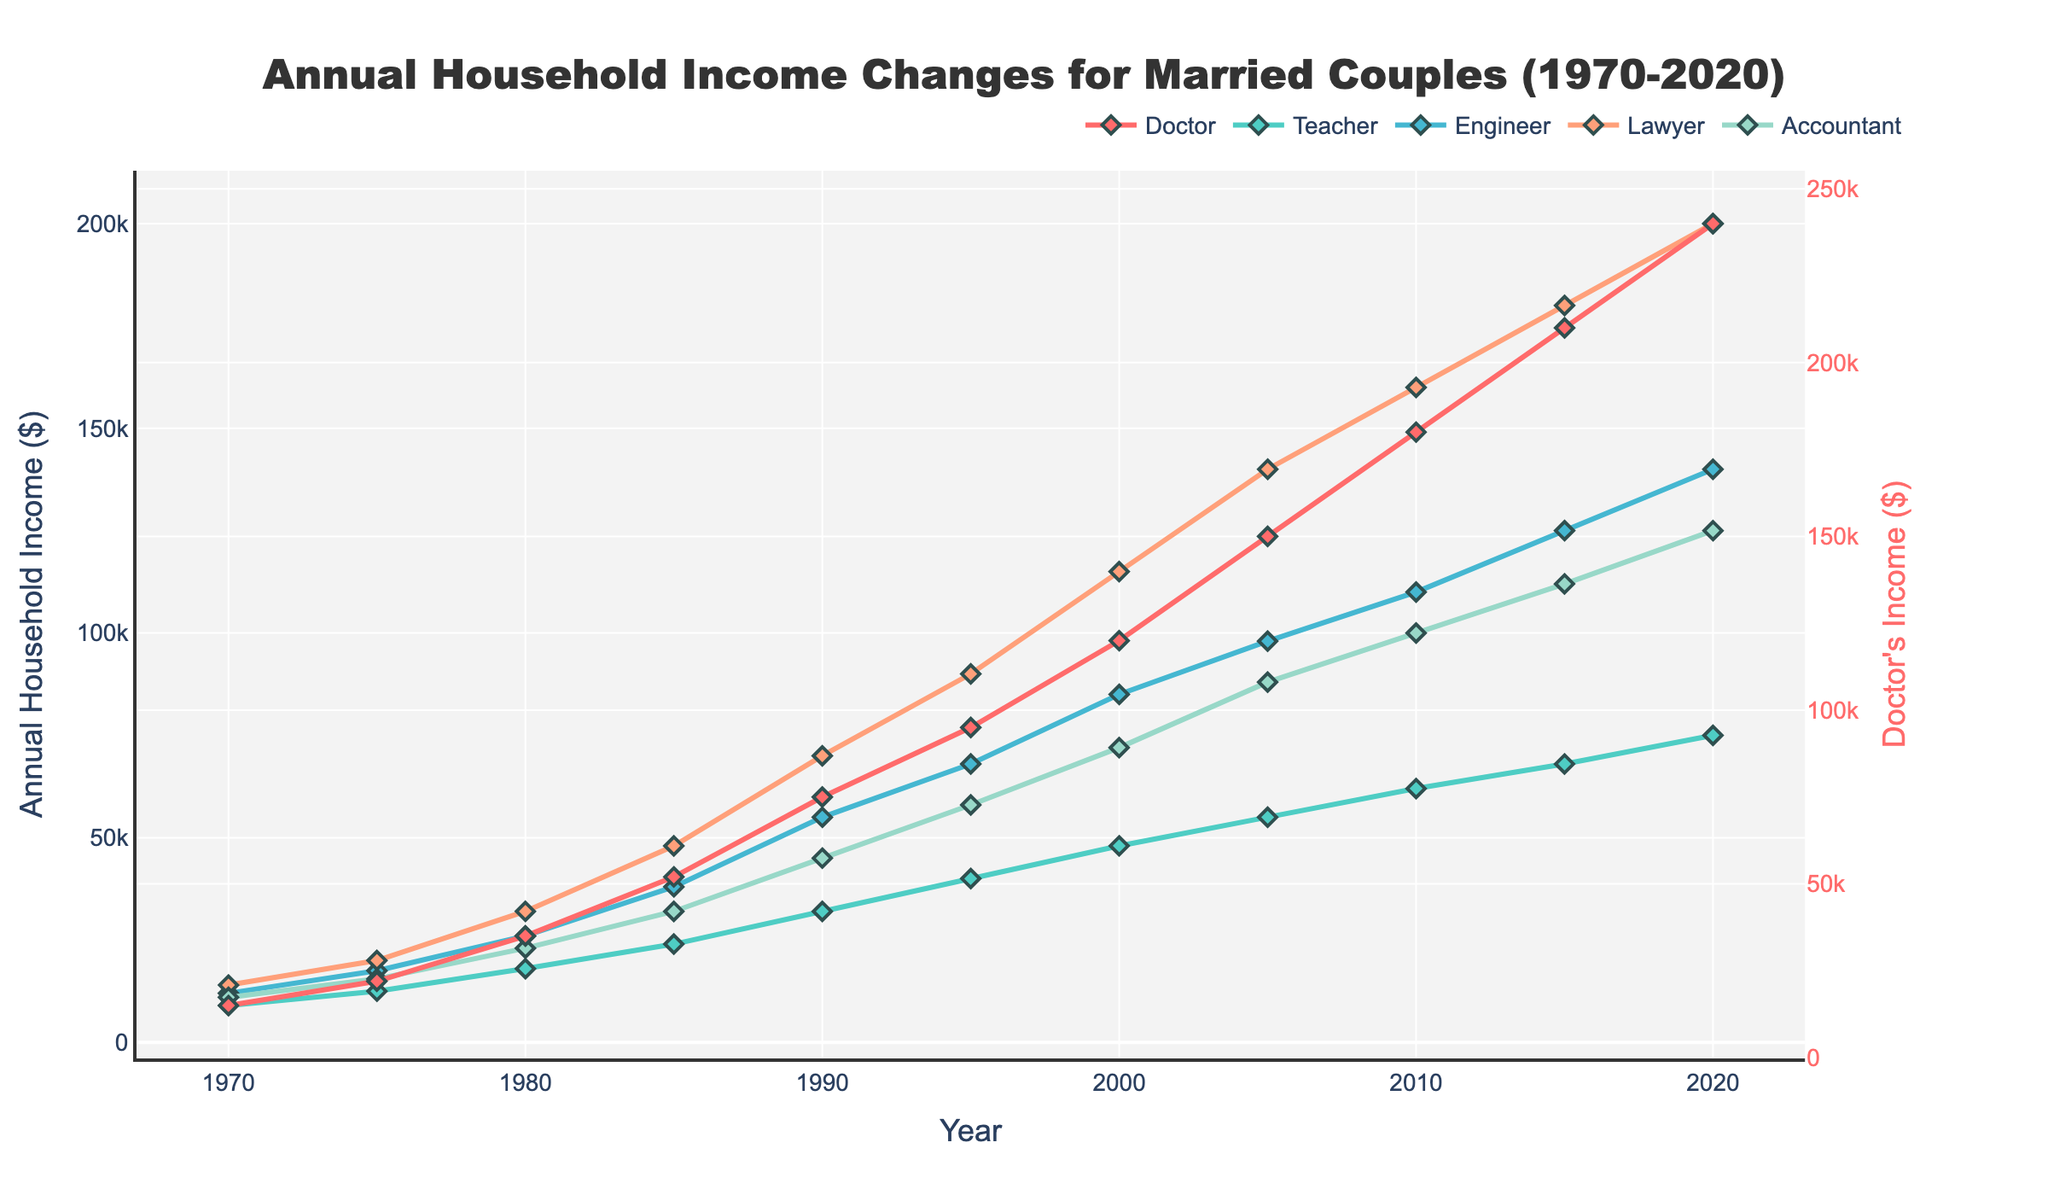What profession has the highest income in 2020? The line chart shows different professions and their incomes over the years. Looking at the year 2020, the highest income is noted for Doctors.
Answer: Doctor Which profession had the smallest increase in income from 1970 to 2020? By examining the line chart, check the starting and ending income values for each profession from 1970 to 2020. Teachers have the smallest increase as their income rises from $9,000 to $75,000, a $66,000 increase.
Answer: Teacher Between 1980 and 1990, which two professions show the largest and smallest income rises? Looking at the income differences from 1980 to 1990, Doctors increase by $40,000 (from $35,000 to $75,000) which is the largest. Teachers show an increase of $14,000 (from $18,000 to $32,000), the smallest.
Answer: Largest: Doctor, Smallest: Teacher In which year did Engineers' income exceed $100,000? The line chart's trend for Engineers shows that their income first exceeds $100,000 in 2005, where it hits $98,000. By 2010, it's at $110,000. So the closest year is 2010.
Answer: 2010 How do the incomes of Lawyers and Accountants in 1995 compare? Looking at the chart for 1995, Lawyers' income is $90,000, while Accountants' income is $58,000. Lawyers earn more than Accountants by $32,000.
Answer: Lawyers earn $32,000 more What is the average income for Teachers from 1970 to 2020? To find the average, sum the incomes of Teachers from 1970 ($9,000), 1975 ($12,500), 1980 ($18,000), 1985 ($24,000), 1990 ($32,000), 1995 ($40,000), 2000 ($48,000), 2005 ($55,000), 2010 ($62,000), 2015 ($68,000), 2020 ($75,000) and divide by the number of years (11). The sum is $443,500. Dividing by 11, the average is $40,318.18.
Answer: $40,318.18 Which professions had incomes surpassing $200,000 by 2020? By examining the incomes for 2020, Doctors and Lawyers surpass the $200,000 mark with incomes of $240,000 and $200,000 respectively.
Answer: Doctor, Lawyer What is the difference in income between Doctors and Teachers in 2000? For 2000, the income of Doctors is $120,000, and for Teachers, it's $48,000. The difference is $120,000 - $48,000 = $72,000.
Answer: $72,000 How did the income trends for Engineers and Accountants compare from 1970 to 2020? The chart shows Engineers starting at $12,000 in 1970 and ending at $140,000 in 2020, whereas Accountants started at $11,000 and ended at $125,000. Both show consistent rises, but Engineers had a slightly steeper increase overall.
Answer: Engineers had a steeper increase Which year did Teachers' income first surpass $50,000? Reviewing the line chart, Teachers' income first surpasses $50,000 in the year 2005 when it reaches $55,000.
Answer: 2005 